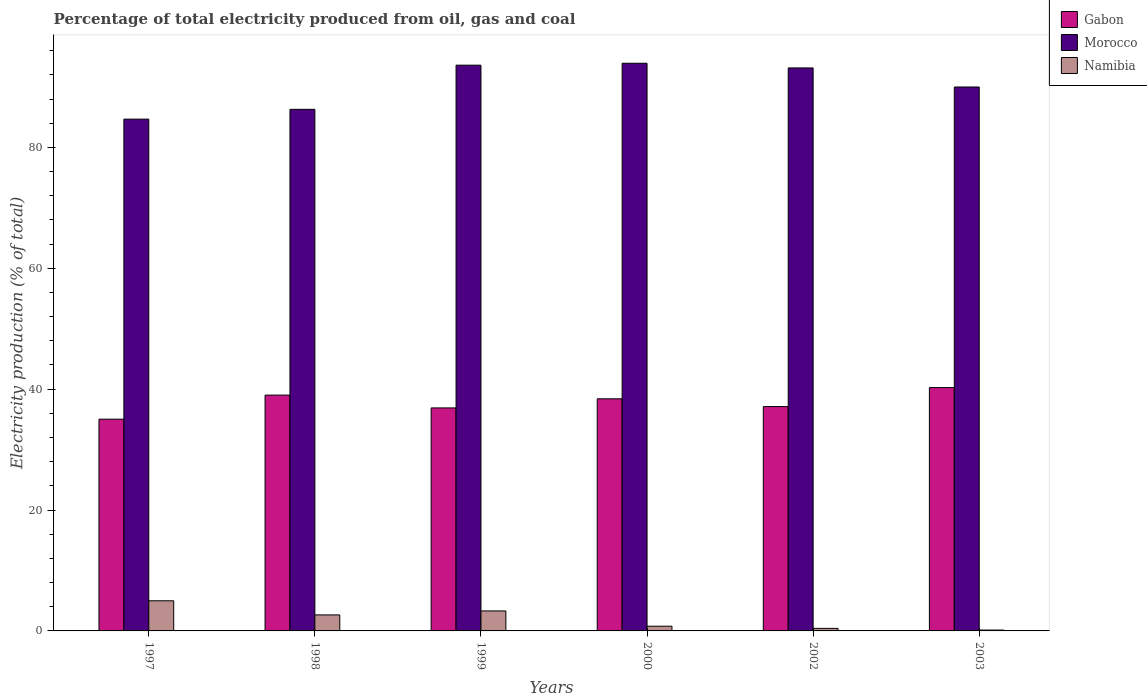How many different coloured bars are there?
Your response must be concise. 3. Are the number of bars per tick equal to the number of legend labels?
Ensure brevity in your answer.  Yes. What is the electricity production in in Gabon in 1999?
Provide a short and direct response. 36.9. Across all years, what is the maximum electricity production in in Namibia?
Make the answer very short. 4.98. Across all years, what is the minimum electricity production in in Namibia?
Your answer should be very brief. 0.14. In which year was the electricity production in in Morocco minimum?
Your answer should be very brief. 1997. What is the total electricity production in in Morocco in the graph?
Your response must be concise. 541.64. What is the difference between the electricity production in in Namibia in 1999 and that in 2000?
Offer a very short reply. 2.53. What is the difference between the electricity production in in Namibia in 2002 and the electricity production in in Gabon in 1999?
Make the answer very short. -36.48. What is the average electricity production in in Gabon per year?
Ensure brevity in your answer.  37.79. In the year 1999, what is the difference between the electricity production in in Gabon and electricity production in in Morocco?
Ensure brevity in your answer.  -56.7. What is the ratio of the electricity production in in Gabon in 1999 to that in 2000?
Your response must be concise. 0.96. Is the electricity production in in Gabon in 1999 less than that in 2000?
Offer a very short reply. Yes. Is the difference between the electricity production in in Gabon in 1998 and 1999 greater than the difference between the electricity production in in Morocco in 1998 and 1999?
Provide a succinct answer. Yes. What is the difference between the highest and the second highest electricity production in in Morocco?
Make the answer very short. 0.32. What is the difference between the highest and the lowest electricity production in in Gabon?
Offer a very short reply. 5.23. In how many years, is the electricity production in in Morocco greater than the average electricity production in in Morocco taken over all years?
Ensure brevity in your answer.  3. What does the 1st bar from the left in 1997 represents?
Provide a succinct answer. Gabon. What does the 2nd bar from the right in 1999 represents?
Give a very brief answer. Morocco. Is it the case that in every year, the sum of the electricity production in in Morocco and electricity production in in Namibia is greater than the electricity production in in Gabon?
Provide a short and direct response. Yes. How many bars are there?
Make the answer very short. 18. Are all the bars in the graph horizontal?
Your answer should be compact. No. Does the graph contain any zero values?
Make the answer very short. No. Does the graph contain grids?
Your answer should be compact. No. Where does the legend appear in the graph?
Give a very brief answer. Top right. How are the legend labels stacked?
Your answer should be very brief. Vertical. What is the title of the graph?
Keep it short and to the point. Percentage of total electricity produced from oil, gas and coal. Does "Thailand" appear as one of the legend labels in the graph?
Ensure brevity in your answer.  No. What is the label or title of the X-axis?
Provide a short and direct response. Years. What is the label or title of the Y-axis?
Make the answer very short. Electricity production (% of total). What is the Electricity production (% of total) of Gabon in 1997?
Offer a very short reply. 35.03. What is the Electricity production (% of total) of Morocco in 1997?
Your answer should be very brief. 84.68. What is the Electricity production (% of total) of Namibia in 1997?
Your response must be concise. 4.98. What is the Electricity production (% of total) of Gabon in 1998?
Offer a terse response. 39.02. What is the Electricity production (% of total) of Morocco in 1998?
Your answer should be very brief. 86.3. What is the Electricity production (% of total) of Namibia in 1998?
Offer a terse response. 2.65. What is the Electricity production (% of total) of Gabon in 1999?
Ensure brevity in your answer.  36.9. What is the Electricity production (% of total) of Morocco in 1999?
Your answer should be compact. 93.6. What is the Electricity production (% of total) of Namibia in 1999?
Make the answer very short. 3.31. What is the Electricity production (% of total) of Gabon in 2000?
Keep it short and to the point. 38.4. What is the Electricity production (% of total) in Morocco in 2000?
Ensure brevity in your answer.  93.92. What is the Electricity production (% of total) of Namibia in 2000?
Make the answer very short. 0.78. What is the Electricity production (% of total) in Gabon in 2002?
Keep it short and to the point. 37.12. What is the Electricity production (% of total) in Morocco in 2002?
Offer a terse response. 93.15. What is the Electricity production (% of total) of Namibia in 2002?
Offer a terse response. 0.42. What is the Electricity production (% of total) of Gabon in 2003?
Offer a terse response. 40.26. What is the Electricity production (% of total) of Morocco in 2003?
Provide a succinct answer. 89.99. What is the Electricity production (% of total) in Namibia in 2003?
Give a very brief answer. 0.14. Across all years, what is the maximum Electricity production (% of total) in Gabon?
Your answer should be compact. 40.26. Across all years, what is the maximum Electricity production (% of total) in Morocco?
Provide a short and direct response. 93.92. Across all years, what is the maximum Electricity production (% of total) of Namibia?
Provide a short and direct response. 4.98. Across all years, what is the minimum Electricity production (% of total) in Gabon?
Your answer should be very brief. 35.03. Across all years, what is the minimum Electricity production (% of total) in Morocco?
Ensure brevity in your answer.  84.68. Across all years, what is the minimum Electricity production (% of total) of Namibia?
Your response must be concise. 0.14. What is the total Electricity production (% of total) of Gabon in the graph?
Keep it short and to the point. 226.73. What is the total Electricity production (% of total) in Morocco in the graph?
Keep it short and to the point. 541.64. What is the total Electricity production (% of total) of Namibia in the graph?
Provide a short and direct response. 12.29. What is the difference between the Electricity production (% of total) of Gabon in 1997 and that in 1998?
Keep it short and to the point. -3.99. What is the difference between the Electricity production (% of total) in Morocco in 1997 and that in 1998?
Your answer should be compact. -1.62. What is the difference between the Electricity production (% of total) in Namibia in 1997 and that in 1998?
Your answer should be compact. 2.33. What is the difference between the Electricity production (% of total) of Gabon in 1997 and that in 1999?
Your response must be concise. -1.87. What is the difference between the Electricity production (% of total) of Morocco in 1997 and that in 1999?
Your answer should be compact. -8.93. What is the difference between the Electricity production (% of total) of Namibia in 1997 and that in 1999?
Offer a very short reply. 1.68. What is the difference between the Electricity production (% of total) of Gabon in 1997 and that in 2000?
Provide a short and direct response. -3.37. What is the difference between the Electricity production (% of total) in Morocco in 1997 and that in 2000?
Your response must be concise. -9.24. What is the difference between the Electricity production (% of total) of Namibia in 1997 and that in 2000?
Your answer should be very brief. 4.2. What is the difference between the Electricity production (% of total) of Gabon in 1997 and that in 2002?
Your answer should be very brief. -2.09. What is the difference between the Electricity production (% of total) of Morocco in 1997 and that in 2002?
Provide a short and direct response. -8.47. What is the difference between the Electricity production (% of total) in Namibia in 1997 and that in 2002?
Provide a succinct answer. 4.56. What is the difference between the Electricity production (% of total) of Gabon in 1997 and that in 2003?
Make the answer very short. -5.23. What is the difference between the Electricity production (% of total) in Morocco in 1997 and that in 2003?
Give a very brief answer. -5.32. What is the difference between the Electricity production (% of total) in Namibia in 1997 and that in 2003?
Provide a succinct answer. 4.84. What is the difference between the Electricity production (% of total) of Gabon in 1998 and that in 1999?
Provide a succinct answer. 2.12. What is the difference between the Electricity production (% of total) of Morocco in 1998 and that in 1999?
Your answer should be very brief. -7.31. What is the difference between the Electricity production (% of total) in Namibia in 1998 and that in 1999?
Provide a succinct answer. -0.66. What is the difference between the Electricity production (% of total) of Gabon in 1998 and that in 2000?
Offer a terse response. 0.61. What is the difference between the Electricity production (% of total) of Morocco in 1998 and that in 2000?
Offer a terse response. -7.62. What is the difference between the Electricity production (% of total) in Namibia in 1998 and that in 2000?
Your answer should be compact. 1.87. What is the difference between the Electricity production (% of total) of Gabon in 1998 and that in 2002?
Give a very brief answer. 1.9. What is the difference between the Electricity production (% of total) in Morocco in 1998 and that in 2002?
Keep it short and to the point. -6.85. What is the difference between the Electricity production (% of total) in Namibia in 1998 and that in 2002?
Provide a succinct answer. 2.23. What is the difference between the Electricity production (% of total) of Gabon in 1998 and that in 2003?
Make the answer very short. -1.25. What is the difference between the Electricity production (% of total) in Morocco in 1998 and that in 2003?
Your response must be concise. -3.7. What is the difference between the Electricity production (% of total) in Namibia in 1998 and that in 2003?
Ensure brevity in your answer.  2.51. What is the difference between the Electricity production (% of total) of Gabon in 1999 and that in 2000?
Ensure brevity in your answer.  -1.51. What is the difference between the Electricity production (% of total) of Morocco in 1999 and that in 2000?
Make the answer very short. -0.32. What is the difference between the Electricity production (% of total) of Namibia in 1999 and that in 2000?
Provide a short and direct response. 2.53. What is the difference between the Electricity production (% of total) in Gabon in 1999 and that in 2002?
Provide a short and direct response. -0.22. What is the difference between the Electricity production (% of total) of Morocco in 1999 and that in 2002?
Ensure brevity in your answer.  0.45. What is the difference between the Electricity production (% of total) in Namibia in 1999 and that in 2002?
Your response must be concise. 2.89. What is the difference between the Electricity production (% of total) in Gabon in 1999 and that in 2003?
Your answer should be compact. -3.37. What is the difference between the Electricity production (% of total) of Morocco in 1999 and that in 2003?
Your response must be concise. 3.61. What is the difference between the Electricity production (% of total) of Namibia in 1999 and that in 2003?
Make the answer very short. 3.17. What is the difference between the Electricity production (% of total) of Gabon in 2000 and that in 2002?
Make the answer very short. 1.28. What is the difference between the Electricity production (% of total) in Morocco in 2000 and that in 2002?
Your response must be concise. 0.77. What is the difference between the Electricity production (% of total) in Namibia in 2000 and that in 2002?
Provide a succinct answer. 0.36. What is the difference between the Electricity production (% of total) in Gabon in 2000 and that in 2003?
Your response must be concise. -1.86. What is the difference between the Electricity production (% of total) in Morocco in 2000 and that in 2003?
Give a very brief answer. 3.93. What is the difference between the Electricity production (% of total) in Namibia in 2000 and that in 2003?
Offer a very short reply. 0.64. What is the difference between the Electricity production (% of total) in Gabon in 2002 and that in 2003?
Your response must be concise. -3.14. What is the difference between the Electricity production (% of total) in Morocco in 2002 and that in 2003?
Ensure brevity in your answer.  3.15. What is the difference between the Electricity production (% of total) of Namibia in 2002 and that in 2003?
Make the answer very short. 0.28. What is the difference between the Electricity production (% of total) in Gabon in 1997 and the Electricity production (% of total) in Morocco in 1998?
Offer a very short reply. -51.27. What is the difference between the Electricity production (% of total) of Gabon in 1997 and the Electricity production (% of total) of Namibia in 1998?
Ensure brevity in your answer.  32.38. What is the difference between the Electricity production (% of total) in Morocco in 1997 and the Electricity production (% of total) in Namibia in 1998?
Offer a very short reply. 82.03. What is the difference between the Electricity production (% of total) of Gabon in 1997 and the Electricity production (% of total) of Morocco in 1999?
Your answer should be very brief. -58.57. What is the difference between the Electricity production (% of total) of Gabon in 1997 and the Electricity production (% of total) of Namibia in 1999?
Provide a short and direct response. 31.72. What is the difference between the Electricity production (% of total) of Morocco in 1997 and the Electricity production (% of total) of Namibia in 1999?
Make the answer very short. 81.37. What is the difference between the Electricity production (% of total) of Gabon in 1997 and the Electricity production (% of total) of Morocco in 2000?
Keep it short and to the point. -58.89. What is the difference between the Electricity production (% of total) in Gabon in 1997 and the Electricity production (% of total) in Namibia in 2000?
Your response must be concise. 34.25. What is the difference between the Electricity production (% of total) of Morocco in 1997 and the Electricity production (% of total) of Namibia in 2000?
Your answer should be compact. 83.89. What is the difference between the Electricity production (% of total) in Gabon in 1997 and the Electricity production (% of total) in Morocco in 2002?
Ensure brevity in your answer.  -58.12. What is the difference between the Electricity production (% of total) in Gabon in 1997 and the Electricity production (% of total) in Namibia in 2002?
Your response must be concise. 34.61. What is the difference between the Electricity production (% of total) in Morocco in 1997 and the Electricity production (% of total) in Namibia in 2002?
Make the answer very short. 84.26. What is the difference between the Electricity production (% of total) of Gabon in 1997 and the Electricity production (% of total) of Morocco in 2003?
Provide a short and direct response. -54.96. What is the difference between the Electricity production (% of total) in Gabon in 1997 and the Electricity production (% of total) in Namibia in 2003?
Your answer should be compact. 34.89. What is the difference between the Electricity production (% of total) of Morocco in 1997 and the Electricity production (% of total) of Namibia in 2003?
Offer a terse response. 84.54. What is the difference between the Electricity production (% of total) of Gabon in 1998 and the Electricity production (% of total) of Morocco in 1999?
Provide a succinct answer. -54.59. What is the difference between the Electricity production (% of total) in Gabon in 1998 and the Electricity production (% of total) in Namibia in 1999?
Provide a short and direct response. 35.71. What is the difference between the Electricity production (% of total) of Morocco in 1998 and the Electricity production (% of total) of Namibia in 1999?
Provide a short and direct response. 82.99. What is the difference between the Electricity production (% of total) in Gabon in 1998 and the Electricity production (% of total) in Morocco in 2000?
Make the answer very short. -54.9. What is the difference between the Electricity production (% of total) in Gabon in 1998 and the Electricity production (% of total) in Namibia in 2000?
Offer a very short reply. 38.24. What is the difference between the Electricity production (% of total) in Morocco in 1998 and the Electricity production (% of total) in Namibia in 2000?
Your answer should be compact. 85.52. What is the difference between the Electricity production (% of total) of Gabon in 1998 and the Electricity production (% of total) of Morocco in 2002?
Your answer should be compact. -54.13. What is the difference between the Electricity production (% of total) in Gabon in 1998 and the Electricity production (% of total) in Namibia in 2002?
Provide a short and direct response. 38.6. What is the difference between the Electricity production (% of total) of Morocco in 1998 and the Electricity production (% of total) of Namibia in 2002?
Your response must be concise. 85.88. What is the difference between the Electricity production (% of total) of Gabon in 1998 and the Electricity production (% of total) of Morocco in 2003?
Provide a succinct answer. -50.98. What is the difference between the Electricity production (% of total) of Gabon in 1998 and the Electricity production (% of total) of Namibia in 2003?
Provide a short and direct response. 38.88. What is the difference between the Electricity production (% of total) of Morocco in 1998 and the Electricity production (% of total) of Namibia in 2003?
Your answer should be very brief. 86.16. What is the difference between the Electricity production (% of total) of Gabon in 1999 and the Electricity production (% of total) of Morocco in 2000?
Offer a terse response. -57.02. What is the difference between the Electricity production (% of total) in Gabon in 1999 and the Electricity production (% of total) in Namibia in 2000?
Ensure brevity in your answer.  36.12. What is the difference between the Electricity production (% of total) in Morocco in 1999 and the Electricity production (% of total) in Namibia in 2000?
Your answer should be very brief. 92.82. What is the difference between the Electricity production (% of total) in Gabon in 1999 and the Electricity production (% of total) in Morocco in 2002?
Provide a short and direct response. -56.25. What is the difference between the Electricity production (% of total) in Gabon in 1999 and the Electricity production (% of total) in Namibia in 2002?
Your answer should be very brief. 36.48. What is the difference between the Electricity production (% of total) in Morocco in 1999 and the Electricity production (% of total) in Namibia in 2002?
Make the answer very short. 93.18. What is the difference between the Electricity production (% of total) in Gabon in 1999 and the Electricity production (% of total) in Morocco in 2003?
Keep it short and to the point. -53.1. What is the difference between the Electricity production (% of total) in Gabon in 1999 and the Electricity production (% of total) in Namibia in 2003?
Your answer should be compact. 36.76. What is the difference between the Electricity production (% of total) in Morocco in 1999 and the Electricity production (% of total) in Namibia in 2003?
Your answer should be compact. 93.46. What is the difference between the Electricity production (% of total) of Gabon in 2000 and the Electricity production (% of total) of Morocco in 2002?
Make the answer very short. -54.74. What is the difference between the Electricity production (% of total) of Gabon in 2000 and the Electricity production (% of total) of Namibia in 2002?
Provide a short and direct response. 37.98. What is the difference between the Electricity production (% of total) of Morocco in 2000 and the Electricity production (% of total) of Namibia in 2002?
Give a very brief answer. 93.5. What is the difference between the Electricity production (% of total) of Gabon in 2000 and the Electricity production (% of total) of Morocco in 2003?
Your answer should be very brief. -51.59. What is the difference between the Electricity production (% of total) of Gabon in 2000 and the Electricity production (% of total) of Namibia in 2003?
Your response must be concise. 38.26. What is the difference between the Electricity production (% of total) in Morocco in 2000 and the Electricity production (% of total) in Namibia in 2003?
Your answer should be compact. 93.78. What is the difference between the Electricity production (% of total) in Gabon in 2002 and the Electricity production (% of total) in Morocco in 2003?
Keep it short and to the point. -52.87. What is the difference between the Electricity production (% of total) in Gabon in 2002 and the Electricity production (% of total) in Namibia in 2003?
Make the answer very short. 36.98. What is the difference between the Electricity production (% of total) in Morocco in 2002 and the Electricity production (% of total) in Namibia in 2003?
Your answer should be compact. 93.01. What is the average Electricity production (% of total) of Gabon per year?
Your answer should be very brief. 37.79. What is the average Electricity production (% of total) in Morocco per year?
Your response must be concise. 90.27. What is the average Electricity production (% of total) in Namibia per year?
Your answer should be very brief. 2.05. In the year 1997, what is the difference between the Electricity production (% of total) of Gabon and Electricity production (% of total) of Morocco?
Provide a short and direct response. -49.64. In the year 1997, what is the difference between the Electricity production (% of total) of Gabon and Electricity production (% of total) of Namibia?
Your answer should be compact. 30.05. In the year 1997, what is the difference between the Electricity production (% of total) in Morocco and Electricity production (% of total) in Namibia?
Offer a terse response. 79.69. In the year 1998, what is the difference between the Electricity production (% of total) of Gabon and Electricity production (% of total) of Morocco?
Ensure brevity in your answer.  -47.28. In the year 1998, what is the difference between the Electricity production (% of total) of Gabon and Electricity production (% of total) of Namibia?
Your response must be concise. 36.37. In the year 1998, what is the difference between the Electricity production (% of total) in Morocco and Electricity production (% of total) in Namibia?
Your answer should be compact. 83.65. In the year 1999, what is the difference between the Electricity production (% of total) in Gabon and Electricity production (% of total) in Morocco?
Offer a terse response. -56.7. In the year 1999, what is the difference between the Electricity production (% of total) in Gabon and Electricity production (% of total) in Namibia?
Keep it short and to the point. 33.59. In the year 1999, what is the difference between the Electricity production (% of total) of Morocco and Electricity production (% of total) of Namibia?
Offer a very short reply. 90.29. In the year 2000, what is the difference between the Electricity production (% of total) of Gabon and Electricity production (% of total) of Morocco?
Your answer should be compact. -55.52. In the year 2000, what is the difference between the Electricity production (% of total) of Gabon and Electricity production (% of total) of Namibia?
Your answer should be compact. 37.62. In the year 2000, what is the difference between the Electricity production (% of total) of Morocco and Electricity production (% of total) of Namibia?
Offer a very short reply. 93.14. In the year 2002, what is the difference between the Electricity production (% of total) of Gabon and Electricity production (% of total) of Morocco?
Make the answer very short. -56.03. In the year 2002, what is the difference between the Electricity production (% of total) in Gabon and Electricity production (% of total) in Namibia?
Ensure brevity in your answer.  36.7. In the year 2002, what is the difference between the Electricity production (% of total) in Morocco and Electricity production (% of total) in Namibia?
Your answer should be very brief. 92.73. In the year 2003, what is the difference between the Electricity production (% of total) of Gabon and Electricity production (% of total) of Morocco?
Give a very brief answer. -49.73. In the year 2003, what is the difference between the Electricity production (% of total) in Gabon and Electricity production (% of total) in Namibia?
Keep it short and to the point. 40.12. In the year 2003, what is the difference between the Electricity production (% of total) of Morocco and Electricity production (% of total) of Namibia?
Your response must be concise. 89.85. What is the ratio of the Electricity production (% of total) in Gabon in 1997 to that in 1998?
Your answer should be compact. 0.9. What is the ratio of the Electricity production (% of total) in Morocco in 1997 to that in 1998?
Make the answer very short. 0.98. What is the ratio of the Electricity production (% of total) of Namibia in 1997 to that in 1998?
Ensure brevity in your answer.  1.88. What is the ratio of the Electricity production (% of total) of Gabon in 1997 to that in 1999?
Give a very brief answer. 0.95. What is the ratio of the Electricity production (% of total) in Morocco in 1997 to that in 1999?
Offer a very short reply. 0.9. What is the ratio of the Electricity production (% of total) in Namibia in 1997 to that in 1999?
Keep it short and to the point. 1.51. What is the ratio of the Electricity production (% of total) in Gabon in 1997 to that in 2000?
Keep it short and to the point. 0.91. What is the ratio of the Electricity production (% of total) of Morocco in 1997 to that in 2000?
Provide a succinct answer. 0.9. What is the ratio of the Electricity production (% of total) of Namibia in 1997 to that in 2000?
Provide a succinct answer. 6.38. What is the ratio of the Electricity production (% of total) of Gabon in 1997 to that in 2002?
Give a very brief answer. 0.94. What is the ratio of the Electricity production (% of total) in Morocco in 1997 to that in 2002?
Provide a succinct answer. 0.91. What is the ratio of the Electricity production (% of total) in Namibia in 1997 to that in 2002?
Keep it short and to the point. 11.87. What is the ratio of the Electricity production (% of total) in Gabon in 1997 to that in 2003?
Offer a very short reply. 0.87. What is the ratio of the Electricity production (% of total) in Morocco in 1997 to that in 2003?
Your response must be concise. 0.94. What is the ratio of the Electricity production (% of total) in Namibia in 1997 to that in 2003?
Give a very brief answer. 35.41. What is the ratio of the Electricity production (% of total) in Gabon in 1998 to that in 1999?
Give a very brief answer. 1.06. What is the ratio of the Electricity production (% of total) of Morocco in 1998 to that in 1999?
Provide a succinct answer. 0.92. What is the ratio of the Electricity production (% of total) of Namibia in 1998 to that in 1999?
Offer a terse response. 0.8. What is the ratio of the Electricity production (% of total) in Morocco in 1998 to that in 2000?
Keep it short and to the point. 0.92. What is the ratio of the Electricity production (% of total) in Namibia in 1998 to that in 2000?
Provide a short and direct response. 3.39. What is the ratio of the Electricity production (% of total) of Gabon in 1998 to that in 2002?
Keep it short and to the point. 1.05. What is the ratio of the Electricity production (% of total) of Morocco in 1998 to that in 2002?
Offer a very short reply. 0.93. What is the ratio of the Electricity production (% of total) of Namibia in 1998 to that in 2002?
Offer a very short reply. 6.31. What is the ratio of the Electricity production (% of total) in Gabon in 1998 to that in 2003?
Offer a very short reply. 0.97. What is the ratio of the Electricity production (% of total) in Morocco in 1998 to that in 2003?
Provide a short and direct response. 0.96. What is the ratio of the Electricity production (% of total) of Namibia in 1998 to that in 2003?
Keep it short and to the point. 18.83. What is the ratio of the Electricity production (% of total) of Gabon in 1999 to that in 2000?
Offer a terse response. 0.96. What is the ratio of the Electricity production (% of total) in Morocco in 1999 to that in 2000?
Provide a short and direct response. 1. What is the ratio of the Electricity production (% of total) in Namibia in 1999 to that in 2000?
Offer a terse response. 4.23. What is the ratio of the Electricity production (% of total) of Gabon in 1999 to that in 2002?
Your answer should be compact. 0.99. What is the ratio of the Electricity production (% of total) of Morocco in 1999 to that in 2002?
Provide a succinct answer. 1. What is the ratio of the Electricity production (% of total) in Namibia in 1999 to that in 2002?
Offer a very short reply. 7.88. What is the ratio of the Electricity production (% of total) in Gabon in 1999 to that in 2003?
Your answer should be compact. 0.92. What is the ratio of the Electricity production (% of total) of Morocco in 1999 to that in 2003?
Your answer should be very brief. 1.04. What is the ratio of the Electricity production (% of total) in Namibia in 1999 to that in 2003?
Offer a very short reply. 23.51. What is the ratio of the Electricity production (% of total) in Gabon in 2000 to that in 2002?
Make the answer very short. 1.03. What is the ratio of the Electricity production (% of total) in Morocco in 2000 to that in 2002?
Your answer should be very brief. 1.01. What is the ratio of the Electricity production (% of total) of Namibia in 2000 to that in 2002?
Your response must be concise. 1.86. What is the ratio of the Electricity production (% of total) in Gabon in 2000 to that in 2003?
Ensure brevity in your answer.  0.95. What is the ratio of the Electricity production (% of total) in Morocco in 2000 to that in 2003?
Your response must be concise. 1.04. What is the ratio of the Electricity production (% of total) of Namibia in 2000 to that in 2003?
Ensure brevity in your answer.  5.55. What is the ratio of the Electricity production (% of total) in Gabon in 2002 to that in 2003?
Keep it short and to the point. 0.92. What is the ratio of the Electricity production (% of total) in Morocco in 2002 to that in 2003?
Give a very brief answer. 1.04. What is the ratio of the Electricity production (% of total) in Namibia in 2002 to that in 2003?
Provide a short and direct response. 2.98. What is the difference between the highest and the second highest Electricity production (% of total) of Gabon?
Offer a terse response. 1.25. What is the difference between the highest and the second highest Electricity production (% of total) in Morocco?
Offer a very short reply. 0.32. What is the difference between the highest and the second highest Electricity production (% of total) in Namibia?
Your answer should be very brief. 1.68. What is the difference between the highest and the lowest Electricity production (% of total) in Gabon?
Provide a short and direct response. 5.23. What is the difference between the highest and the lowest Electricity production (% of total) in Morocco?
Give a very brief answer. 9.24. What is the difference between the highest and the lowest Electricity production (% of total) of Namibia?
Give a very brief answer. 4.84. 